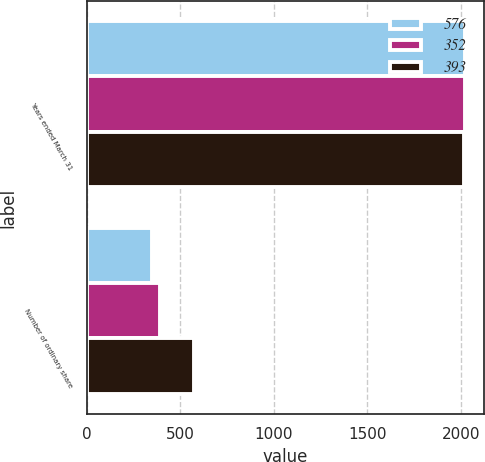<chart> <loc_0><loc_0><loc_500><loc_500><stacked_bar_chart><ecel><fcel>Years ended March 31<fcel>Number of ordinary share<nl><fcel>576<fcel>2019<fcel>352<nl><fcel>352<fcel>2018<fcel>393<nl><fcel>393<fcel>2017<fcel>576<nl></chart> 